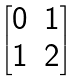Convert formula to latex. <formula><loc_0><loc_0><loc_500><loc_500>\begin{bmatrix} 0 & 1 \\ 1 & 2 \end{bmatrix}</formula> 